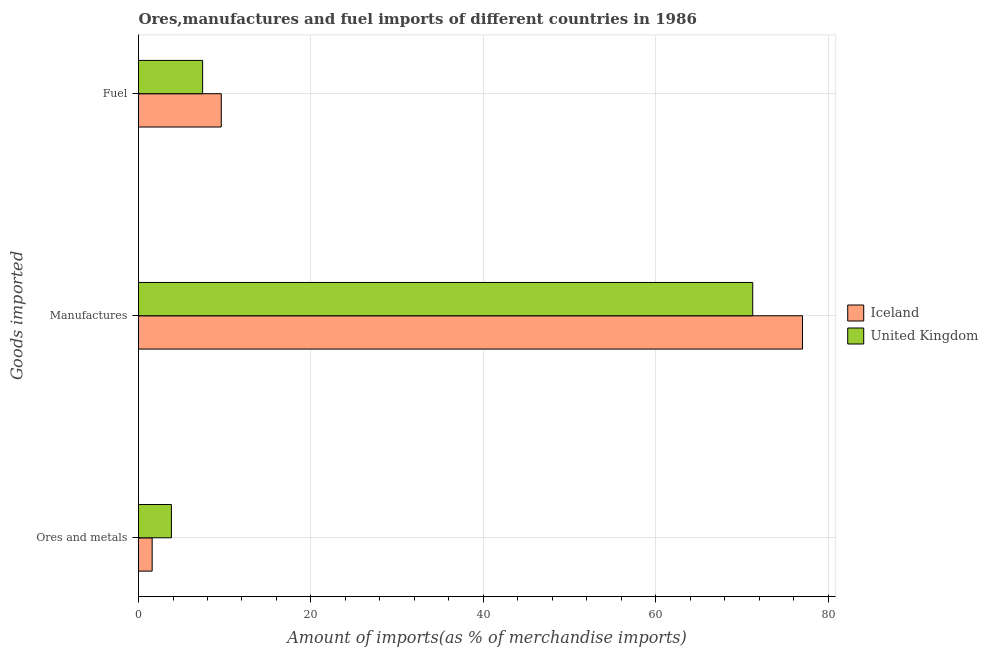Are the number of bars on each tick of the Y-axis equal?
Ensure brevity in your answer.  Yes. How many bars are there on the 1st tick from the top?
Make the answer very short. 2. What is the label of the 3rd group of bars from the top?
Keep it short and to the point. Ores and metals. What is the percentage of fuel imports in United Kingdom?
Provide a short and direct response. 7.44. Across all countries, what is the maximum percentage of manufactures imports?
Ensure brevity in your answer.  77.01. Across all countries, what is the minimum percentage of manufactures imports?
Keep it short and to the point. 71.24. In which country was the percentage of manufactures imports minimum?
Offer a very short reply. United Kingdom. What is the total percentage of ores and metals imports in the graph?
Your response must be concise. 5.4. What is the difference between the percentage of manufactures imports in United Kingdom and that in Iceland?
Your answer should be compact. -5.77. What is the difference between the percentage of fuel imports in Iceland and the percentage of ores and metals imports in United Kingdom?
Give a very brief answer. 5.78. What is the average percentage of ores and metals imports per country?
Ensure brevity in your answer.  2.7. What is the difference between the percentage of ores and metals imports and percentage of fuel imports in Iceland?
Make the answer very short. -8.02. In how many countries, is the percentage of manufactures imports greater than 72 %?
Your answer should be very brief. 1. What is the ratio of the percentage of fuel imports in Iceland to that in United Kingdom?
Your answer should be compact. 1.29. Is the percentage of manufactures imports in United Kingdom less than that in Iceland?
Make the answer very short. Yes. Is the difference between the percentage of manufactures imports in United Kingdom and Iceland greater than the difference between the percentage of fuel imports in United Kingdom and Iceland?
Provide a succinct answer. No. What is the difference between the highest and the second highest percentage of ores and metals imports?
Provide a short and direct response. 2.23. What is the difference between the highest and the lowest percentage of fuel imports?
Provide a succinct answer. 2.16. In how many countries, is the percentage of fuel imports greater than the average percentage of fuel imports taken over all countries?
Offer a terse response. 1. Is the sum of the percentage of manufactures imports in Iceland and United Kingdom greater than the maximum percentage of ores and metals imports across all countries?
Keep it short and to the point. Yes. How many bars are there?
Provide a succinct answer. 6. Are all the bars in the graph horizontal?
Your answer should be compact. Yes. How many countries are there in the graph?
Ensure brevity in your answer.  2. Does the graph contain any zero values?
Make the answer very short. No. Does the graph contain grids?
Ensure brevity in your answer.  Yes. What is the title of the graph?
Ensure brevity in your answer.  Ores,manufactures and fuel imports of different countries in 1986. What is the label or title of the X-axis?
Offer a very short reply. Amount of imports(as % of merchandise imports). What is the label or title of the Y-axis?
Offer a terse response. Goods imported. What is the Amount of imports(as % of merchandise imports) in Iceland in Ores and metals?
Provide a succinct answer. 1.58. What is the Amount of imports(as % of merchandise imports) in United Kingdom in Ores and metals?
Provide a short and direct response. 3.81. What is the Amount of imports(as % of merchandise imports) of Iceland in Manufactures?
Give a very brief answer. 77.01. What is the Amount of imports(as % of merchandise imports) in United Kingdom in Manufactures?
Offer a very short reply. 71.24. What is the Amount of imports(as % of merchandise imports) of Iceland in Fuel?
Ensure brevity in your answer.  9.6. What is the Amount of imports(as % of merchandise imports) in United Kingdom in Fuel?
Keep it short and to the point. 7.44. Across all Goods imported, what is the maximum Amount of imports(as % of merchandise imports) in Iceland?
Provide a succinct answer. 77.01. Across all Goods imported, what is the maximum Amount of imports(as % of merchandise imports) in United Kingdom?
Provide a succinct answer. 71.24. Across all Goods imported, what is the minimum Amount of imports(as % of merchandise imports) in Iceland?
Make the answer very short. 1.58. Across all Goods imported, what is the minimum Amount of imports(as % of merchandise imports) of United Kingdom?
Provide a succinct answer. 3.81. What is the total Amount of imports(as % of merchandise imports) in Iceland in the graph?
Your response must be concise. 88.19. What is the total Amount of imports(as % of merchandise imports) in United Kingdom in the graph?
Keep it short and to the point. 82.49. What is the difference between the Amount of imports(as % of merchandise imports) of Iceland in Ores and metals and that in Manufactures?
Provide a short and direct response. -75.43. What is the difference between the Amount of imports(as % of merchandise imports) in United Kingdom in Ores and metals and that in Manufactures?
Provide a short and direct response. -67.42. What is the difference between the Amount of imports(as % of merchandise imports) in Iceland in Ores and metals and that in Fuel?
Make the answer very short. -8.02. What is the difference between the Amount of imports(as % of merchandise imports) in United Kingdom in Ores and metals and that in Fuel?
Your answer should be compact. -3.62. What is the difference between the Amount of imports(as % of merchandise imports) of Iceland in Manufactures and that in Fuel?
Provide a short and direct response. 67.41. What is the difference between the Amount of imports(as % of merchandise imports) in United Kingdom in Manufactures and that in Fuel?
Your answer should be compact. 63.8. What is the difference between the Amount of imports(as % of merchandise imports) of Iceland in Ores and metals and the Amount of imports(as % of merchandise imports) of United Kingdom in Manufactures?
Keep it short and to the point. -69.66. What is the difference between the Amount of imports(as % of merchandise imports) of Iceland in Ores and metals and the Amount of imports(as % of merchandise imports) of United Kingdom in Fuel?
Provide a succinct answer. -5.85. What is the difference between the Amount of imports(as % of merchandise imports) of Iceland in Manufactures and the Amount of imports(as % of merchandise imports) of United Kingdom in Fuel?
Give a very brief answer. 69.57. What is the average Amount of imports(as % of merchandise imports) in Iceland per Goods imported?
Provide a short and direct response. 29.4. What is the average Amount of imports(as % of merchandise imports) of United Kingdom per Goods imported?
Make the answer very short. 27.5. What is the difference between the Amount of imports(as % of merchandise imports) of Iceland and Amount of imports(as % of merchandise imports) of United Kingdom in Ores and metals?
Provide a short and direct response. -2.23. What is the difference between the Amount of imports(as % of merchandise imports) of Iceland and Amount of imports(as % of merchandise imports) of United Kingdom in Manufactures?
Your answer should be compact. 5.77. What is the difference between the Amount of imports(as % of merchandise imports) of Iceland and Amount of imports(as % of merchandise imports) of United Kingdom in Fuel?
Offer a very short reply. 2.16. What is the ratio of the Amount of imports(as % of merchandise imports) of Iceland in Ores and metals to that in Manufactures?
Make the answer very short. 0.02. What is the ratio of the Amount of imports(as % of merchandise imports) in United Kingdom in Ores and metals to that in Manufactures?
Provide a succinct answer. 0.05. What is the ratio of the Amount of imports(as % of merchandise imports) in Iceland in Ores and metals to that in Fuel?
Give a very brief answer. 0.16. What is the ratio of the Amount of imports(as % of merchandise imports) of United Kingdom in Ores and metals to that in Fuel?
Give a very brief answer. 0.51. What is the ratio of the Amount of imports(as % of merchandise imports) in Iceland in Manufactures to that in Fuel?
Offer a terse response. 8.02. What is the ratio of the Amount of imports(as % of merchandise imports) of United Kingdom in Manufactures to that in Fuel?
Offer a terse response. 9.58. What is the difference between the highest and the second highest Amount of imports(as % of merchandise imports) of Iceland?
Provide a short and direct response. 67.41. What is the difference between the highest and the second highest Amount of imports(as % of merchandise imports) in United Kingdom?
Offer a terse response. 63.8. What is the difference between the highest and the lowest Amount of imports(as % of merchandise imports) of Iceland?
Keep it short and to the point. 75.43. What is the difference between the highest and the lowest Amount of imports(as % of merchandise imports) in United Kingdom?
Your answer should be compact. 67.42. 